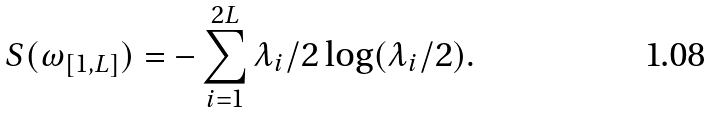<formula> <loc_0><loc_0><loc_500><loc_500>S ( \omega _ { [ 1 , L ] } ) = - \sum _ { i = 1 } ^ { 2 L } \lambda _ { i } / 2 \log ( \lambda _ { i } / 2 ) .</formula> 